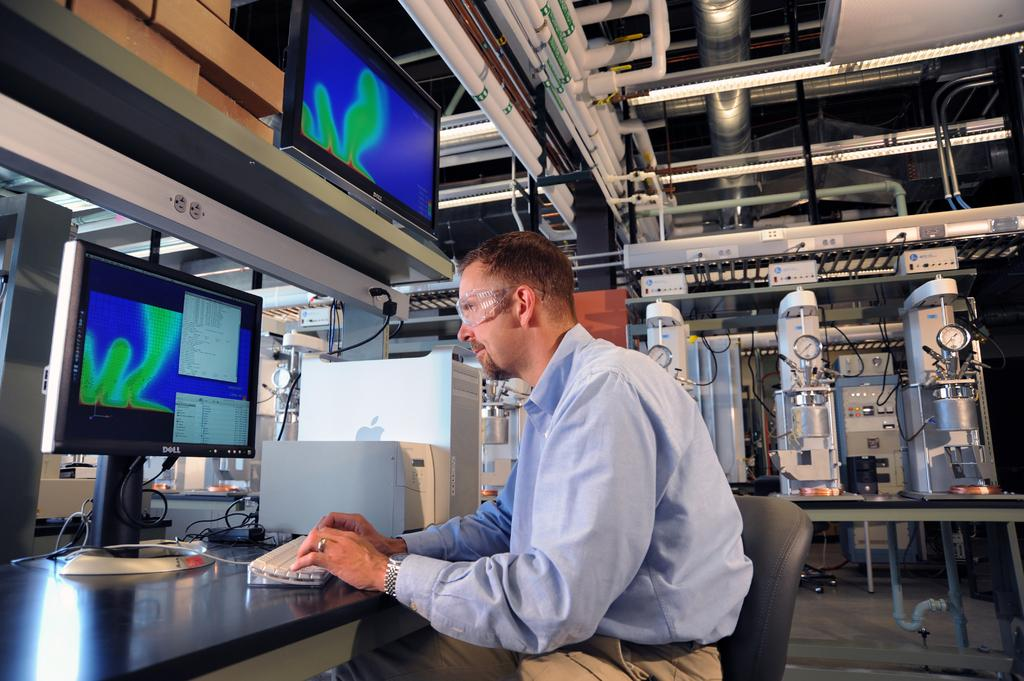What is the man in the image doing? The man is sitting on a chair and typing on a keyboard. What is the man using to type? The man is using a computer to type, as there is a keyboard and a computer visible in the image. Where is the computer located? The computer is on a table in the image. What other components of a computer system can be seen in the image? There is a CPU on the table and an electronic device in the background of the image. What can be seen in the background of the image? In the background, there are pipes, a screen, and an electronic device. How does the man solve the riddle in the image? There is no riddle present in the image; the man is simply typing on a keyboard. What type of coil is used to power the computer in the image? There is no coil mentioned or visible in the image; the computer is powered by a CPU and an electronic device. 